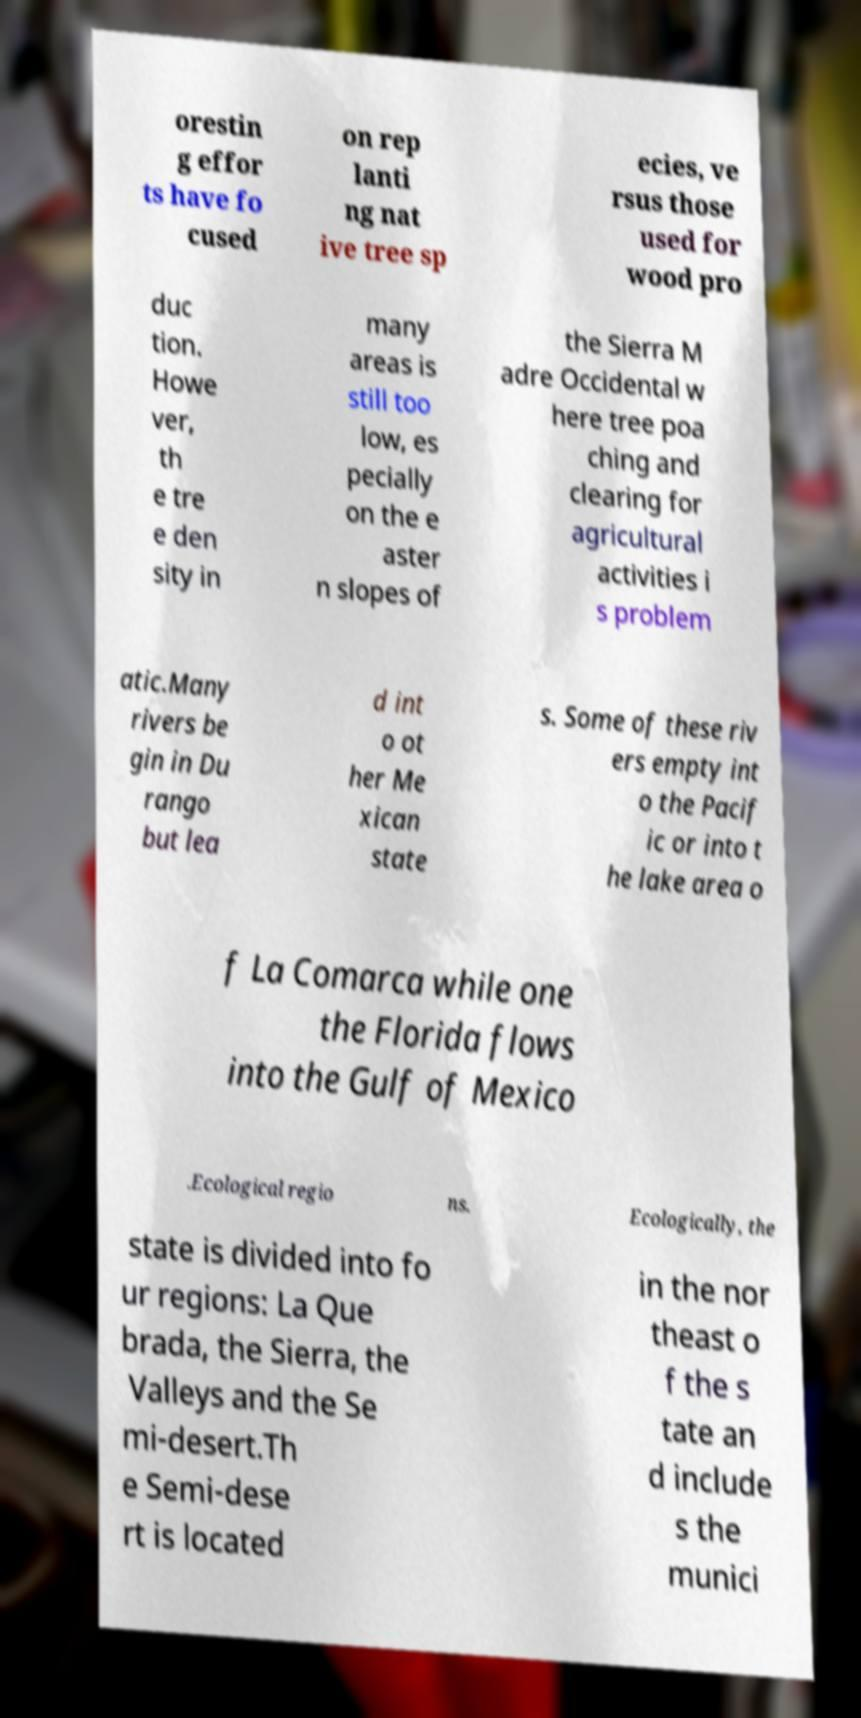Please identify and transcribe the text found in this image. orestin g effor ts have fo cused on rep lanti ng nat ive tree sp ecies, ve rsus those used for wood pro duc tion. Howe ver, th e tre e den sity in many areas is still too low, es pecially on the e aster n slopes of the Sierra M adre Occidental w here tree poa ching and clearing for agricultural activities i s problem atic.Many rivers be gin in Du rango but lea d int o ot her Me xican state s. Some of these riv ers empty int o the Pacif ic or into t he lake area o f La Comarca while one the Florida flows into the Gulf of Mexico .Ecological regio ns. Ecologically, the state is divided into fo ur regions: La Que brada, the Sierra, the Valleys and the Se mi-desert.Th e Semi-dese rt is located in the nor theast o f the s tate an d include s the munici 